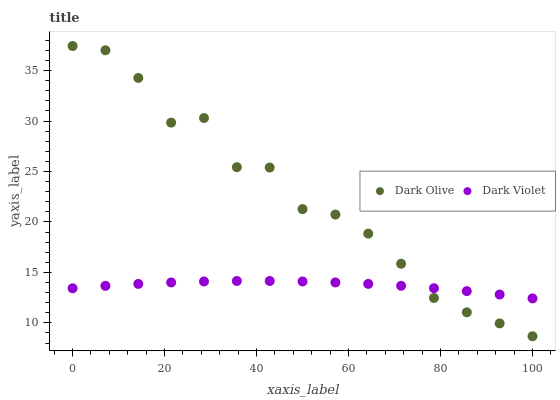Does Dark Violet have the minimum area under the curve?
Answer yes or no. Yes. Does Dark Olive have the maximum area under the curve?
Answer yes or no. Yes. Does Dark Violet have the maximum area under the curve?
Answer yes or no. No. Is Dark Violet the smoothest?
Answer yes or no. Yes. Is Dark Olive the roughest?
Answer yes or no. Yes. Is Dark Violet the roughest?
Answer yes or no. No. Does Dark Olive have the lowest value?
Answer yes or no. Yes. Does Dark Violet have the lowest value?
Answer yes or no. No. Does Dark Olive have the highest value?
Answer yes or no. Yes. Does Dark Violet have the highest value?
Answer yes or no. No. Does Dark Violet intersect Dark Olive?
Answer yes or no. Yes. Is Dark Violet less than Dark Olive?
Answer yes or no. No. Is Dark Violet greater than Dark Olive?
Answer yes or no. No. 